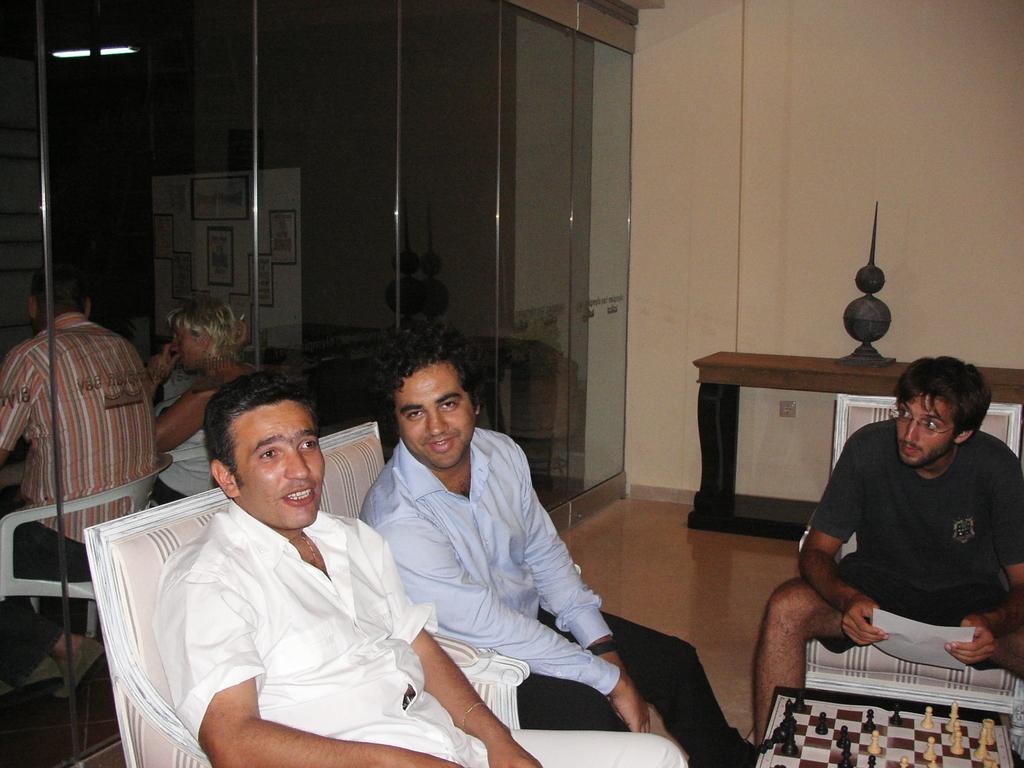Can you describe this image briefly? These three persons are sitting on chairs. This man is holding paper. In-front of this man there is a table, on this table there is a chess board with coins. In this glass there is a reflection of persons, white board with posters and light. On this table there is a decorative item. 